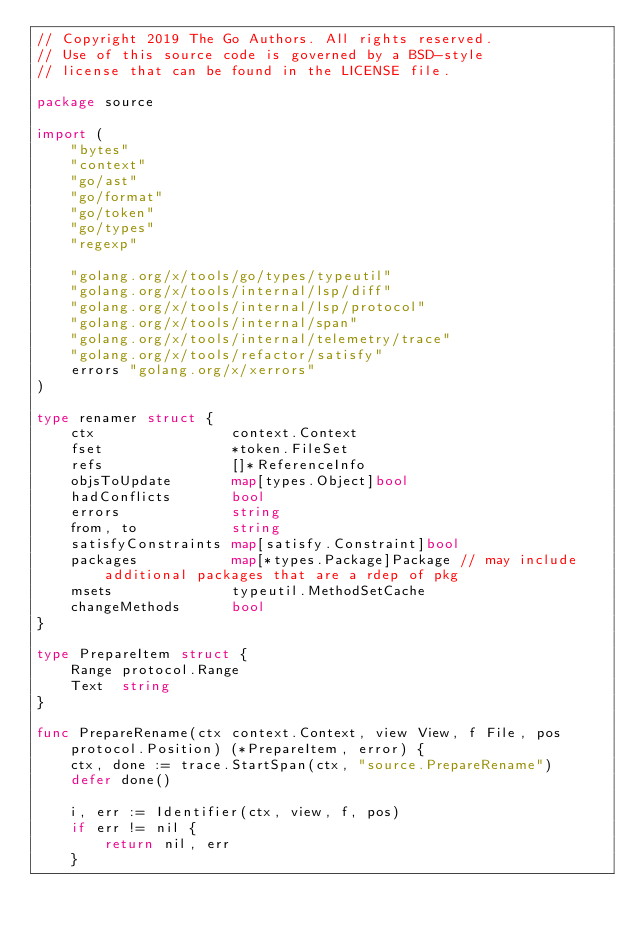Convert code to text. <code><loc_0><loc_0><loc_500><loc_500><_Go_>// Copyright 2019 The Go Authors. All rights reserved.
// Use of this source code is governed by a BSD-style
// license that can be found in the LICENSE file.

package source

import (
	"bytes"
	"context"
	"go/ast"
	"go/format"
	"go/token"
	"go/types"
	"regexp"

	"golang.org/x/tools/go/types/typeutil"
	"golang.org/x/tools/internal/lsp/diff"
	"golang.org/x/tools/internal/lsp/protocol"
	"golang.org/x/tools/internal/span"
	"golang.org/x/tools/internal/telemetry/trace"
	"golang.org/x/tools/refactor/satisfy"
	errors "golang.org/x/xerrors"
)

type renamer struct {
	ctx                context.Context
	fset               *token.FileSet
	refs               []*ReferenceInfo
	objsToUpdate       map[types.Object]bool
	hadConflicts       bool
	errors             string
	from, to           string
	satisfyConstraints map[satisfy.Constraint]bool
	packages           map[*types.Package]Package // may include additional packages that are a rdep of pkg
	msets              typeutil.MethodSetCache
	changeMethods      bool
}

type PrepareItem struct {
	Range protocol.Range
	Text  string
}

func PrepareRename(ctx context.Context, view View, f File, pos protocol.Position) (*PrepareItem, error) {
	ctx, done := trace.StartSpan(ctx, "source.PrepareRename")
	defer done()

	i, err := Identifier(ctx, view, f, pos)
	if err != nil {
		return nil, err
	}
</code> 